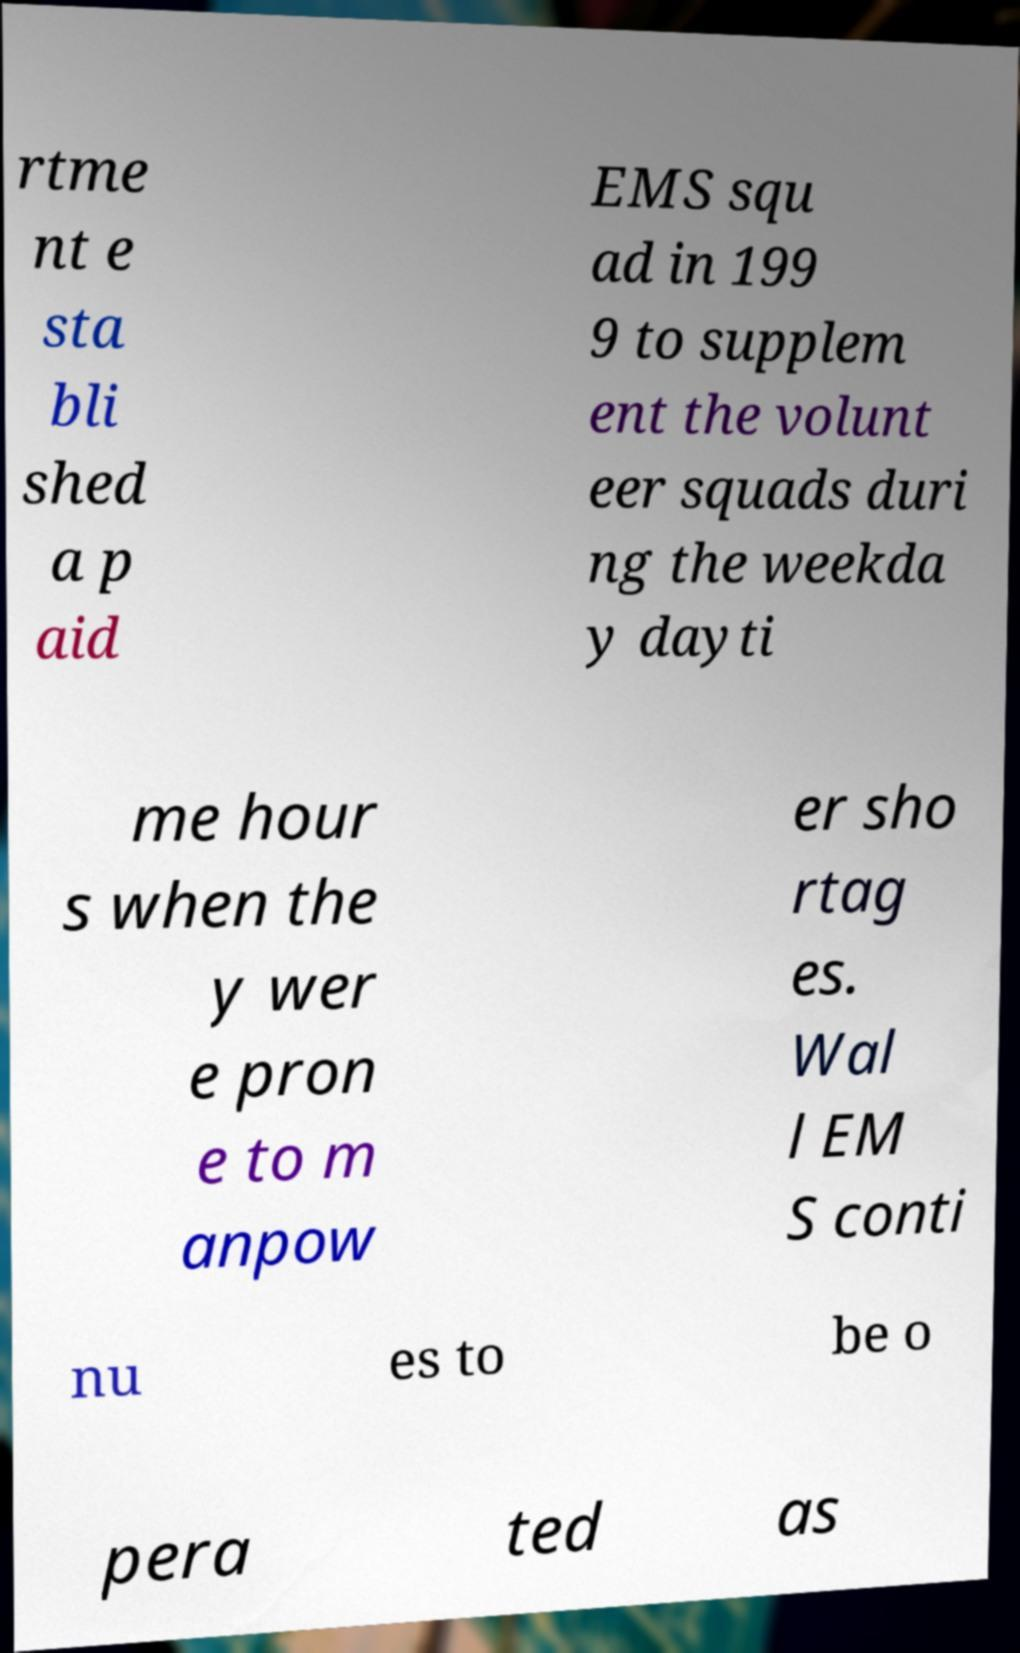There's text embedded in this image that I need extracted. Can you transcribe it verbatim? rtme nt e sta bli shed a p aid EMS squ ad in 199 9 to supplem ent the volunt eer squads duri ng the weekda y dayti me hour s when the y wer e pron e to m anpow er sho rtag es. Wal l EM S conti nu es to be o pera ted as 